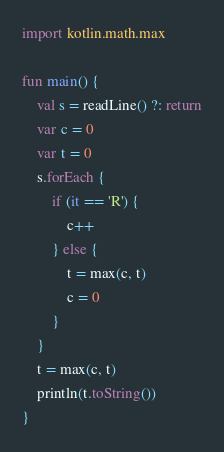<code> <loc_0><loc_0><loc_500><loc_500><_Kotlin_>import kotlin.math.max

fun main() {
    val s = readLine() ?: return
    var c = 0
    var t = 0
    s.forEach {
        if (it == 'R') {
            c++
        } else {
            t = max(c, t)
            c = 0
        }
    }
    t = max(c, t)
    println(t.toString())
}
</code> 